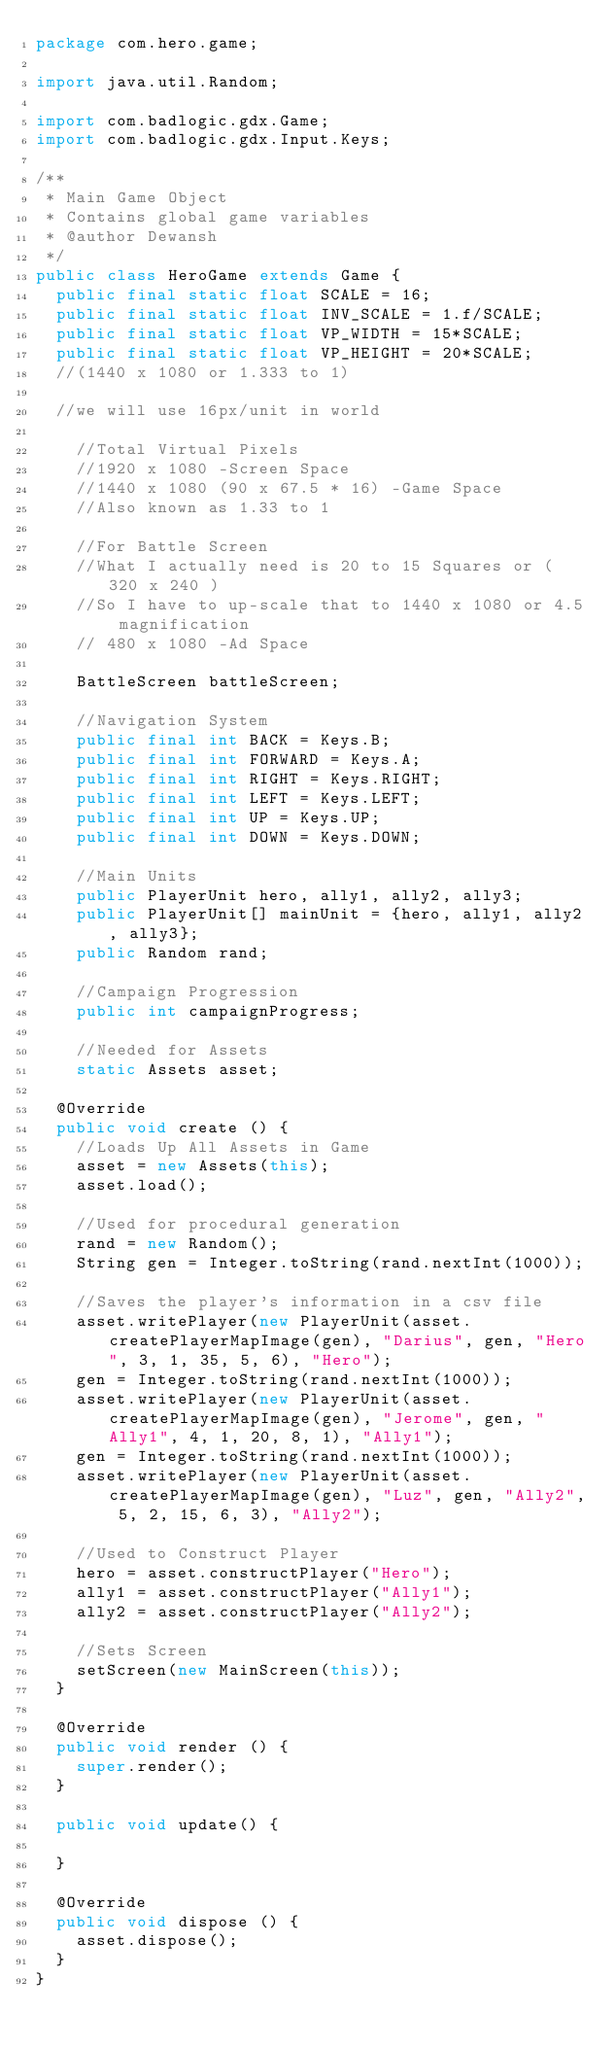<code> <loc_0><loc_0><loc_500><loc_500><_Java_>package com.hero.game;

import java.util.Random;

import com.badlogic.gdx.Game;
import com.badlogic.gdx.Input.Keys;

/**
 * Main Game Object
 * Contains global game variables
 * @author Dewansh
 */
public class HeroGame extends Game {
	public final static float SCALE = 16;
	public final static float INV_SCALE = 1.f/SCALE;
	public final static float VP_WIDTH = 15*SCALE;
	public final static float VP_HEIGHT = 20*SCALE;
	//(1440 x 1080 or 1.333 to 1)

	//we will use 16px/unit in world

		//Total Virtual Pixels
		//1920 x 1080 -Screen Space
		//1440 x 1080 (90 x 67.5 * 16) -Game Space
		//Also known as 1.33 to 1

		//For Battle Screen
		//What I actually need is 20 to 15 Squares or ( 320 x 240 )
		//So I have to up-scale that to 1440 x 1080 or 4.5 magnification
		// 480 x 1080 -Ad Space

		BattleScreen battleScreen;
		
		//Navigation System
		public final int BACK = Keys.B;
		public final int FORWARD = Keys.A;
		public final int RIGHT = Keys.RIGHT;
		public final int LEFT = Keys.LEFT;
		public final int UP = Keys.UP;
		public final int DOWN = Keys.DOWN;

		//Main Units
		public PlayerUnit hero, ally1, ally2, ally3;
		public PlayerUnit[] mainUnit = {hero, ally1, ally2, ally3};
		public Random rand;
		
		//Campaign Progression
		public int campaignProgress;
		
		//Needed for Assets
		static Assets asset;
		
	@Override
	public void create () {
		//Loads Up All Assets in Game
		asset = new Assets(this);
		asset.load();
		
		//Used for procedural generation
		rand = new Random();
		String gen = Integer.toString(rand.nextInt(1000));
		
		//Saves the player's information in a csv file
		asset.writePlayer(new PlayerUnit(asset.createPlayerMapImage(gen), "Darius", gen, "Hero", 3, 1, 35, 5, 6), "Hero");
		gen = Integer.toString(rand.nextInt(1000));
		asset.writePlayer(new PlayerUnit(asset.createPlayerMapImage(gen), "Jerome", gen, "Ally1", 4, 1, 20, 8, 1), "Ally1");
		gen = Integer.toString(rand.nextInt(1000));
		asset.writePlayer(new PlayerUnit(asset.createPlayerMapImage(gen), "Luz", gen, "Ally2", 5, 2, 15, 6, 3), "Ally2");

		//Used to Construct Player
		hero = asset.constructPlayer("Hero");
		ally1 = asset.constructPlayer("Ally1");
		ally2 = asset.constructPlayer("Ally2");
		
		//Sets Screen
		setScreen(new MainScreen(this));
	}

	@Override
	public void render () {
		super.render();
	}

	public void update() {

	}

	@Override
	public void dispose () {
		asset.dispose();
	}
}
</code> 